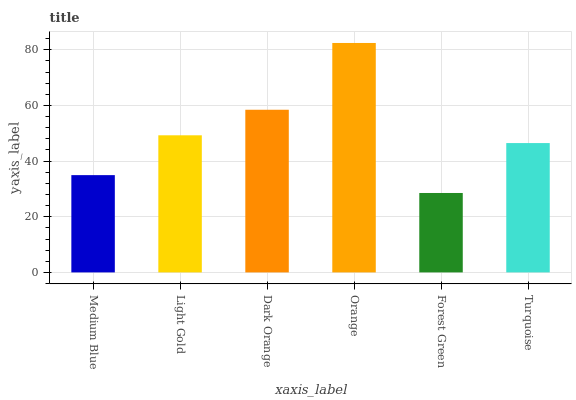Is Forest Green the minimum?
Answer yes or no. Yes. Is Orange the maximum?
Answer yes or no. Yes. Is Light Gold the minimum?
Answer yes or no. No. Is Light Gold the maximum?
Answer yes or no. No. Is Light Gold greater than Medium Blue?
Answer yes or no. Yes. Is Medium Blue less than Light Gold?
Answer yes or no. Yes. Is Medium Blue greater than Light Gold?
Answer yes or no. No. Is Light Gold less than Medium Blue?
Answer yes or no. No. Is Light Gold the high median?
Answer yes or no. Yes. Is Turquoise the low median?
Answer yes or no. Yes. Is Medium Blue the high median?
Answer yes or no. No. Is Dark Orange the low median?
Answer yes or no. No. 